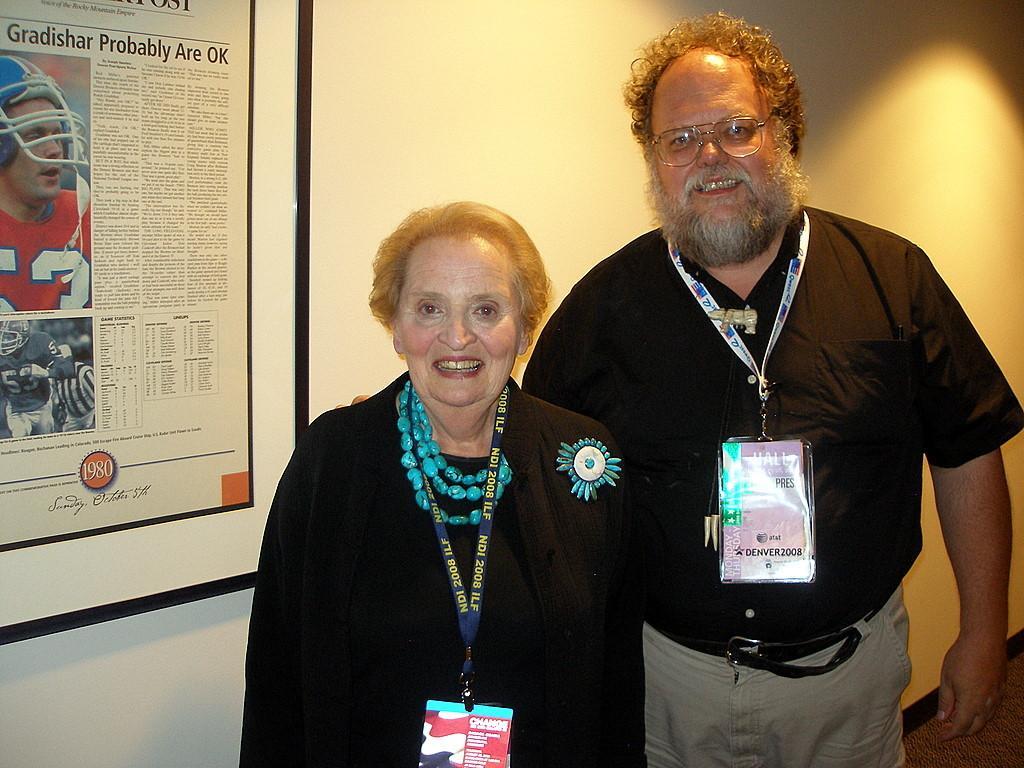Describe this image in one or two sentences. In this image there is a man, he is wearing a black color shirt and grey color pant, beside him there is a woman she is wearing black color coat, in the background there is a wall to that wall there is a photo frame. 